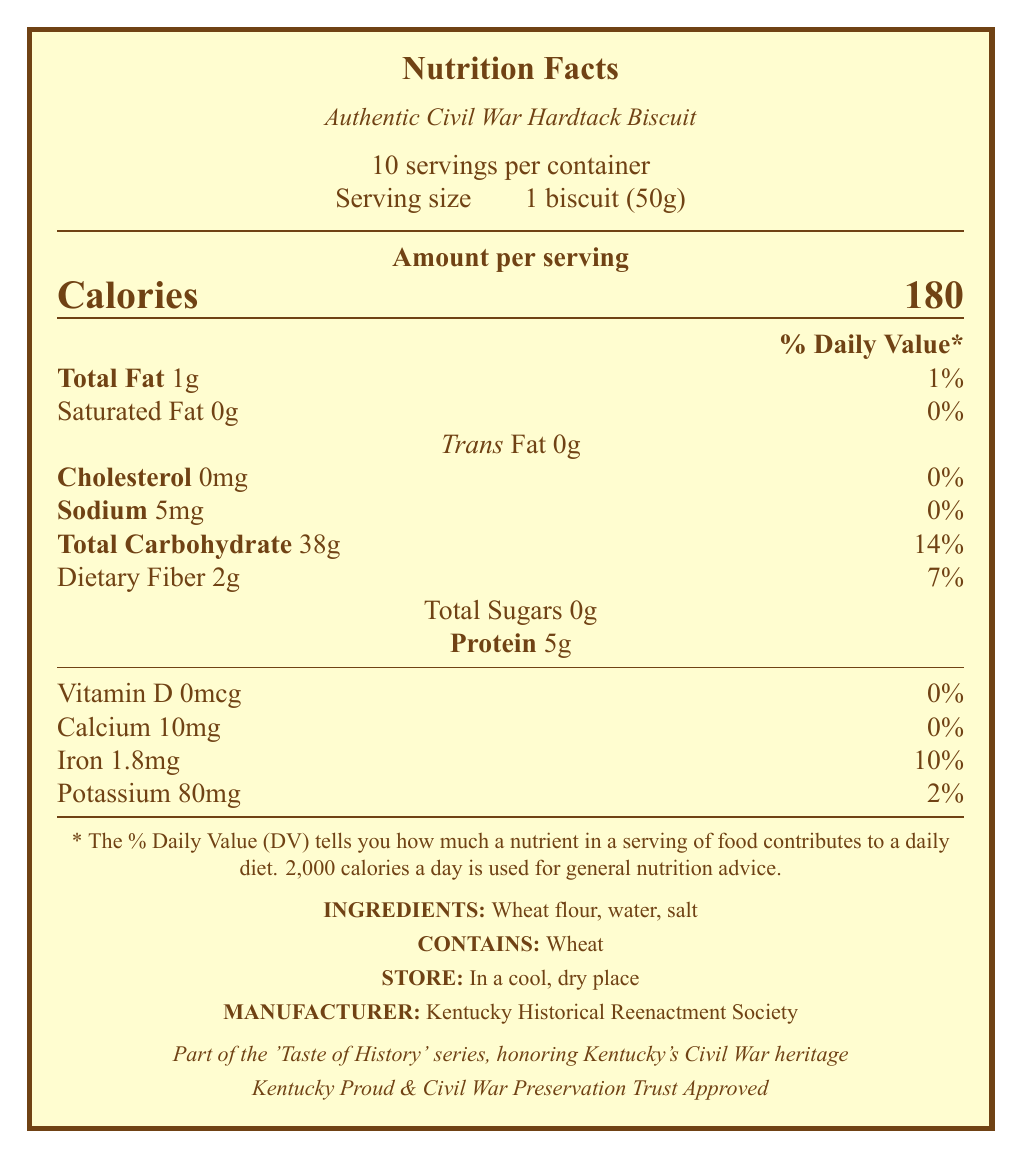what is the serving size? The document specifies the serving size as "1 biscuit (50g)" under the product name.
Answer: 1 biscuit (50g) how many servings are in the container? The document states there are "10 servings per container."
Answer: 10 servings how many calories are in one serving? The document lists "Calories 180" under the "Amount per serving" section.
Answer: 180 calories what are the main ingredients of the hardtack biscuit? The document mentions the ingredients as "Wheat flour, water, salt."
Answer: Wheat flour, water, salt how much protein is in each serving? The document states "Protein 5g" under the nutrient information.
Answer: 5g how much iron does one serving contain? The document specifies "Iron 1.8mg" under nutrition info.
Answer: 1.8mg where should the hardtack be stored? The document advises to "STORE: In a cool, dry place."
Answer: In a cool, dry place which organization produced this hardtack biscuit? The document mentions "MANUFACTURER: Kentucky Historical Reenactment Society."
Answer: Kentucky Historical Reenactment Society how long is the shelf life of the biscuit? The supplementary information indicates a "shelf life: 1 year when stored properly."
Answer: 1 year how much trans fat is in one serving? The document lists "Trans Fat 0g" in the nutritional content.
Answer: 0g how much sodium does each serving have? The document notes "Sodium 5mg" in the nutritional content.
Answer: 5mg how much dietary fiber is in one serving? The document states "Dietary Fiber 2g" under the nutrition facts.
Answer: 2g what vitamins and minerals are present in the biscuit? These are listed under the nutritional section: Vitamin D 0mcg, Calcium 10mg, Iron 1.8mg, Potassium 80mg.
Answer: Vitamin D 0mcg, Calcium 10mg, Iron 1.8mg, Potassium 80mg what percentage of daily value of total carbohydrate does one serving provide? The document states "Total Carbohydrate 38g \hfill 14%" under the nutritional information.
Answer: 14% does the biscuit contain cholesterol? The document mentions "Cholesterol 0mg \hfill 0%" indicating no cholesterol.
Answer: No does this product have any certifications? The document lists "Kentucky Proud" and "Civil War Preservation Trust Approved" as certifications.
Answer: Yes how can the hardtack be prepared for an authentic experience? The preparation tip suggests "soak the biscuit in coffee or crumble into soup" for an authentic experience.
Answer: Soak in coffee or crumble into soup what is a recommended serving pairing for the hardtack? The document suggests serving with "Perryville Battlefield State Historic Site's homemade apple butter."
Answer: Perryville Battlefield State Historic Site's homemade apple butter what is the historical significance of this hardtack biscuit? The historical note states that it was particularly important for Kentucky troops during the Civil War.
Answer: It is a faithful recreation of the staple food consumed by both Union and Confederate soldiers during the American Civil War (1861-1865) how should the biscuit be wrapped for authenticity? The document mentions the biscuit is "Individually wrapped in period-appropriate waxed paper."
Answer: Individually wrapped in period-appropriate waxed paper which of the following is NOT an ingredient in the hardtack biscuit? A. Wheat flour B. Salt C. Baking soda D. Water The ingredients listed are "Wheat flour, water, salt" and do not include baking soda.
Answer: C what is the predominant macronutrient in the hardtack biscuit? A. Protein B. Carbohydrate C. Fat The document indicates "Total Carbohydrate 38g" which is the highest among the macronutrients listed.
Answer: B are there any allergens present in the biscuit? The document states "CONTAINS: Wheat" indicating the presence of allergens.
Answer: Yes is this document part of any specific series? The document mentions it is "Part of the 'Taste of History' series, honoring Kentucky's Civil War heritage."
Answer: Yes what percentage of daily value of calcium does one serving provide? The document lists "Calcium 10mg \hfill 0%" indicating it provides 0% of the daily value.
Answer: 0% describe the main idea of the document The document is centered around presenting a commemorative hardtack biscuit with accurate nutritional details, contextual historical background, and practical usage instructions.
Answer: The document provides nutritional information, historical context, storage instructions, certifications, and preparation tips for an Authentic Civil War Hardtack Biscuit, reproduced using traditional recipes and methods from the Civil War era. how many grams of sugar are in one serving? The document lists "Total Sugars 0g" but does not specify any further details on sugars.
Answer: Cannot be determined what is the daily value percentage for potassium? The document states "Potassium 80mg \hfill 2%" under the nutritional information.
Answer: 2% 